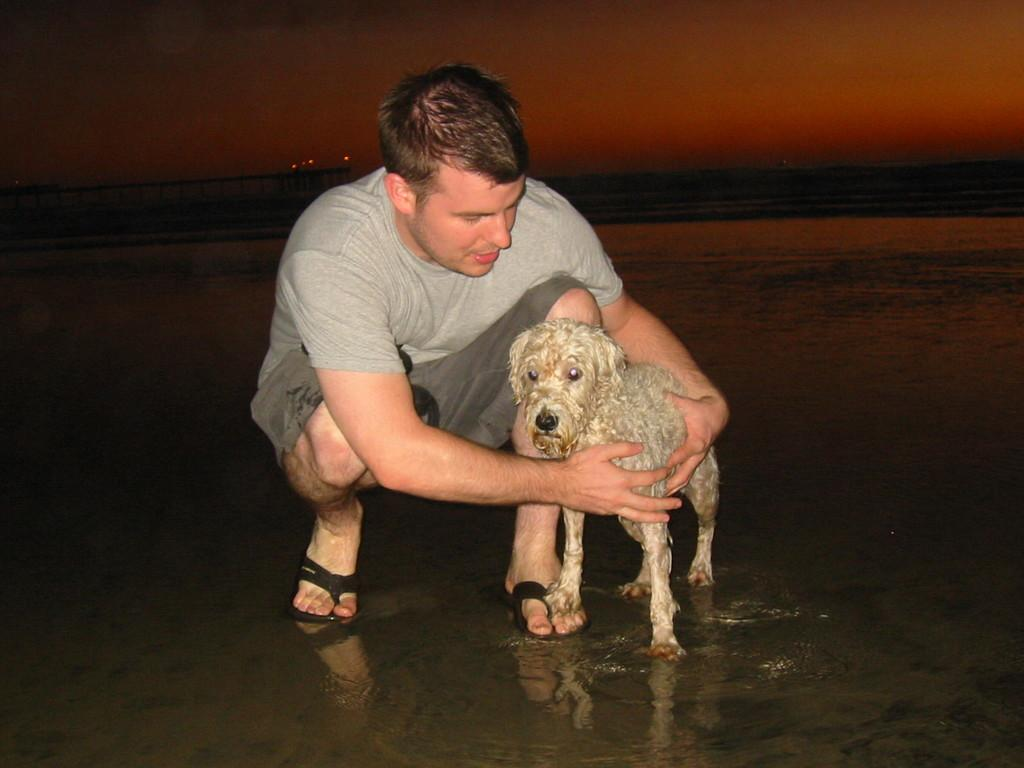Who or what is the main subject in the image? There is a person in the image. What is the person doing in the image? The person is holding a dog. What can be seen in the background of the image? There is water visible in the image. What type of crime is being committed in the image? There is no crime being committed in the image; it features a person holding a dog near water. What type of bun is being used to feed the dog in the image? There is no bun present in the image, and the dog is not being fed. 